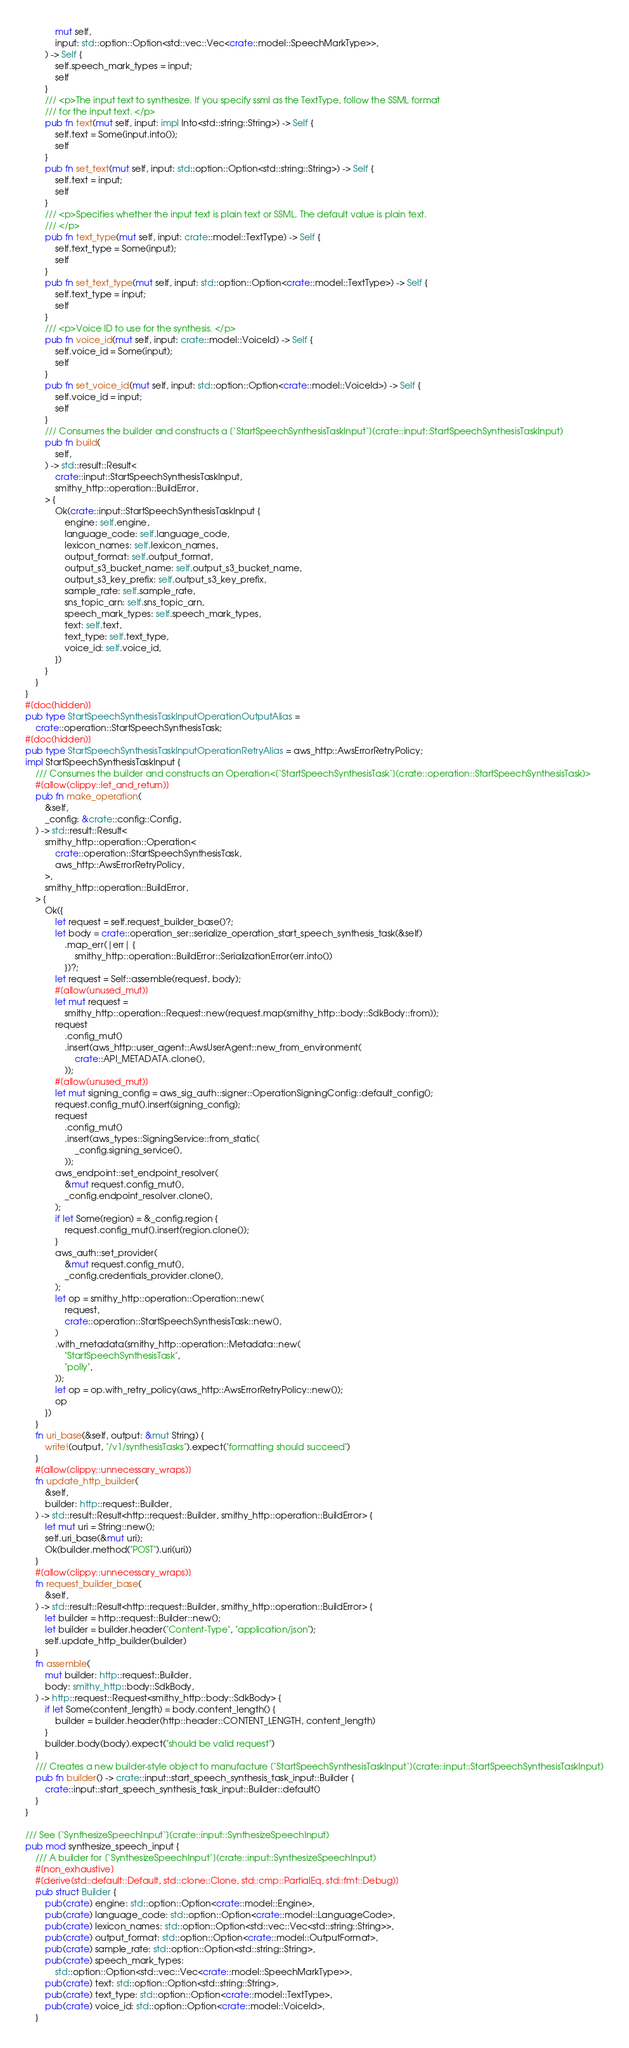<code> <loc_0><loc_0><loc_500><loc_500><_Rust_>            mut self,
            input: std::option::Option<std::vec::Vec<crate::model::SpeechMarkType>>,
        ) -> Self {
            self.speech_mark_types = input;
            self
        }
        /// <p>The input text to synthesize. If you specify ssml as the TextType, follow the SSML format
        /// for the input text. </p>
        pub fn text(mut self, input: impl Into<std::string::String>) -> Self {
            self.text = Some(input.into());
            self
        }
        pub fn set_text(mut self, input: std::option::Option<std::string::String>) -> Self {
            self.text = input;
            self
        }
        /// <p>Specifies whether the input text is plain text or SSML. The default value is plain text.
        /// </p>
        pub fn text_type(mut self, input: crate::model::TextType) -> Self {
            self.text_type = Some(input);
            self
        }
        pub fn set_text_type(mut self, input: std::option::Option<crate::model::TextType>) -> Self {
            self.text_type = input;
            self
        }
        /// <p>Voice ID to use for the synthesis. </p>
        pub fn voice_id(mut self, input: crate::model::VoiceId) -> Self {
            self.voice_id = Some(input);
            self
        }
        pub fn set_voice_id(mut self, input: std::option::Option<crate::model::VoiceId>) -> Self {
            self.voice_id = input;
            self
        }
        /// Consumes the builder and constructs a [`StartSpeechSynthesisTaskInput`](crate::input::StartSpeechSynthesisTaskInput)
        pub fn build(
            self,
        ) -> std::result::Result<
            crate::input::StartSpeechSynthesisTaskInput,
            smithy_http::operation::BuildError,
        > {
            Ok(crate::input::StartSpeechSynthesisTaskInput {
                engine: self.engine,
                language_code: self.language_code,
                lexicon_names: self.lexicon_names,
                output_format: self.output_format,
                output_s3_bucket_name: self.output_s3_bucket_name,
                output_s3_key_prefix: self.output_s3_key_prefix,
                sample_rate: self.sample_rate,
                sns_topic_arn: self.sns_topic_arn,
                speech_mark_types: self.speech_mark_types,
                text: self.text,
                text_type: self.text_type,
                voice_id: self.voice_id,
            })
        }
    }
}
#[doc(hidden)]
pub type StartSpeechSynthesisTaskInputOperationOutputAlias =
    crate::operation::StartSpeechSynthesisTask;
#[doc(hidden)]
pub type StartSpeechSynthesisTaskInputOperationRetryAlias = aws_http::AwsErrorRetryPolicy;
impl StartSpeechSynthesisTaskInput {
    /// Consumes the builder and constructs an Operation<[`StartSpeechSynthesisTask`](crate::operation::StartSpeechSynthesisTask)>
    #[allow(clippy::let_and_return)]
    pub fn make_operation(
        &self,
        _config: &crate::config::Config,
    ) -> std::result::Result<
        smithy_http::operation::Operation<
            crate::operation::StartSpeechSynthesisTask,
            aws_http::AwsErrorRetryPolicy,
        >,
        smithy_http::operation::BuildError,
    > {
        Ok({
            let request = self.request_builder_base()?;
            let body = crate::operation_ser::serialize_operation_start_speech_synthesis_task(&self)
                .map_err(|err| {
                    smithy_http::operation::BuildError::SerializationError(err.into())
                })?;
            let request = Self::assemble(request, body);
            #[allow(unused_mut)]
            let mut request =
                smithy_http::operation::Request::new(request.map(smithy_http::body::SdkBody::from));
            request
                .config_mut()
                .insert(aws_http::user_agent::AwsUserAgent::new_from_environment(
                    crate::API_METADATA.clone(),
                ));
            #[allow(unused_mut)]
            let mut signing_config = aws_sig_auth::signer::OperationSigningConfig::default_config();
            request.config_mut().insert(signing_config);
            request
                .config_mut()
                .insert(aws_types::SigningService::from_static(
                    _config.signing_service(),
                ));
            aws_endpoint::set_endpoint_resolver(
                &mut request.config_mut(),
                _config.endpoint_resolver.clone(),
            );
            if let Some(region) = &_config.region {
                request.config_mut().insert(region.clone());
            }
            aws_auth::set_provider(
                &mut request.config_mut(),
                _config.credentials_provider.clone(),
            );
            let op = smithy_http::operation::Operation::new(
                request,
                crate::operation::StartSpeechSynthesisTask::new(),
            )
            .with_metadata(smithy_http::operation::Metadata::new(
                "StartSpeechSynthesisTask",
                "polly",
            ));
            let op = op.with_retry_policy(aws_http::AwsErrorRetryPolicy::new());
            op
        })
    }
    fn uri_base(&self, output: &mut String) {
        write!(output, "/v1/synthesisTasks").expect("formatting should succeed")
    }
    #[allow(clippy::unnecessary_wraps)]
    fn update_http_builder(
        &self,
        builder: http::request::Builder,
    ) -> std::result::Result<http::request::Builder, smithy_http::operation::BuildError> {
        let mut uri = String::new();
        self.uri_base(&mut uri);
        Ok(builder.method("POST").uri(uri))
    }
    #[allow(clippy::unnecessary_wraps)]
    fn request_builder_base(
        &self,
    ) -> std::result::Result<http::request::Builder, smithy_http::operation::BuildError> {
        let builder = http::request::Builder::new();
        let builder = builder.header("Content-Type", "application/json");
        self.update_http_builder(builder)
    }
    fn assemble(
        mut builder: http::request::Builder,
        body: smithy_http::body::SdkBody,
    ) -> http::request::Request<smithy_http::body::SdkBody> {
        if let Some(content_length) = body.content_length() {
            builder = builder.header(http::header::CONTENT_LENGTH, content_length)
        }
        builder.body(body).expect("should be valid request")
    }
    /// Creates a new builder-style object to manufacture [`StartSpeechSynthesisTaskInput`](crate::input::StartSpeechSynthesisTaskInput)
    pub fn builder() -> crate::input::start_speech_synthesis_task_input::Builder {
        crate::input::start_speech_synthesis_task_input::Builder::default()
    }
}

/// See [`SynthesizeSpeechInput`](crate::input::SynthesizeSpeechInput)
pub mod synthesize_speech_input {
    /// A builder for [`SynthesizeSpeechInput`](crate::input::SynthesizeSpeechInput)
    #[non_exhaustive]
    #[derive(std::default::Default, std::clone::Clone, std::cmp::PartialEq, std::fmt::Debug)]
    pub struct Builder {
        pub(crate) engine: std::option::Option<crate::model::Engine>,
        pub(crate) language_code: std::option::Option<crate::model::LanguageCode>,
        pub(crate) lexicon_names: std::option::Option<std::vec::Vec<std::string::String>>,
        pub(crate) output_format: std::option::Option<crate::model::OutputFormat>,
        pub(crate) sample_rate: std::option::Option<std::string::String>,
        pub(crate) speech_mark_types:
            std::option::Option<std::vec::Vec<crate::model::SpeechMarkType>>,
        pub(crate) text: std::option::Option<std::string::String>,
        pub(crate) text_type: std::option::Option<crate::model::TextType>,
        pub(crate) voice_id: std::option::Option<crate::model::VoiceId>,
    }</code> 